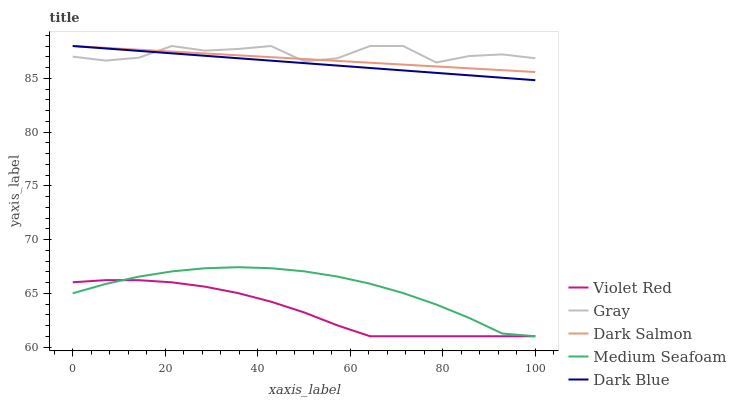Does Dark Salmon have the minimum area under the curve?
Answer yes or no. No. Does Dark Salmon have the maximum area under the curve?
Answer yes or no. No. Is Violet Red the smoothest?
Answer yes or no. No. Is Violet Red the roughest?
Answer yes or no. No. Does Dark Salmon have the lowest value?
Answer yes or no. No. Does Violet Red have the highest value?
Answer yes or no. No. Is Medium Seafoam less than Gray?
Answer yes or no. Yes. Is Dark Blue greater than Medium Seafoam?
Answer yes or no. Yes. Does Medium Seafoam intersect Gray?
Answer yes or no. No. 